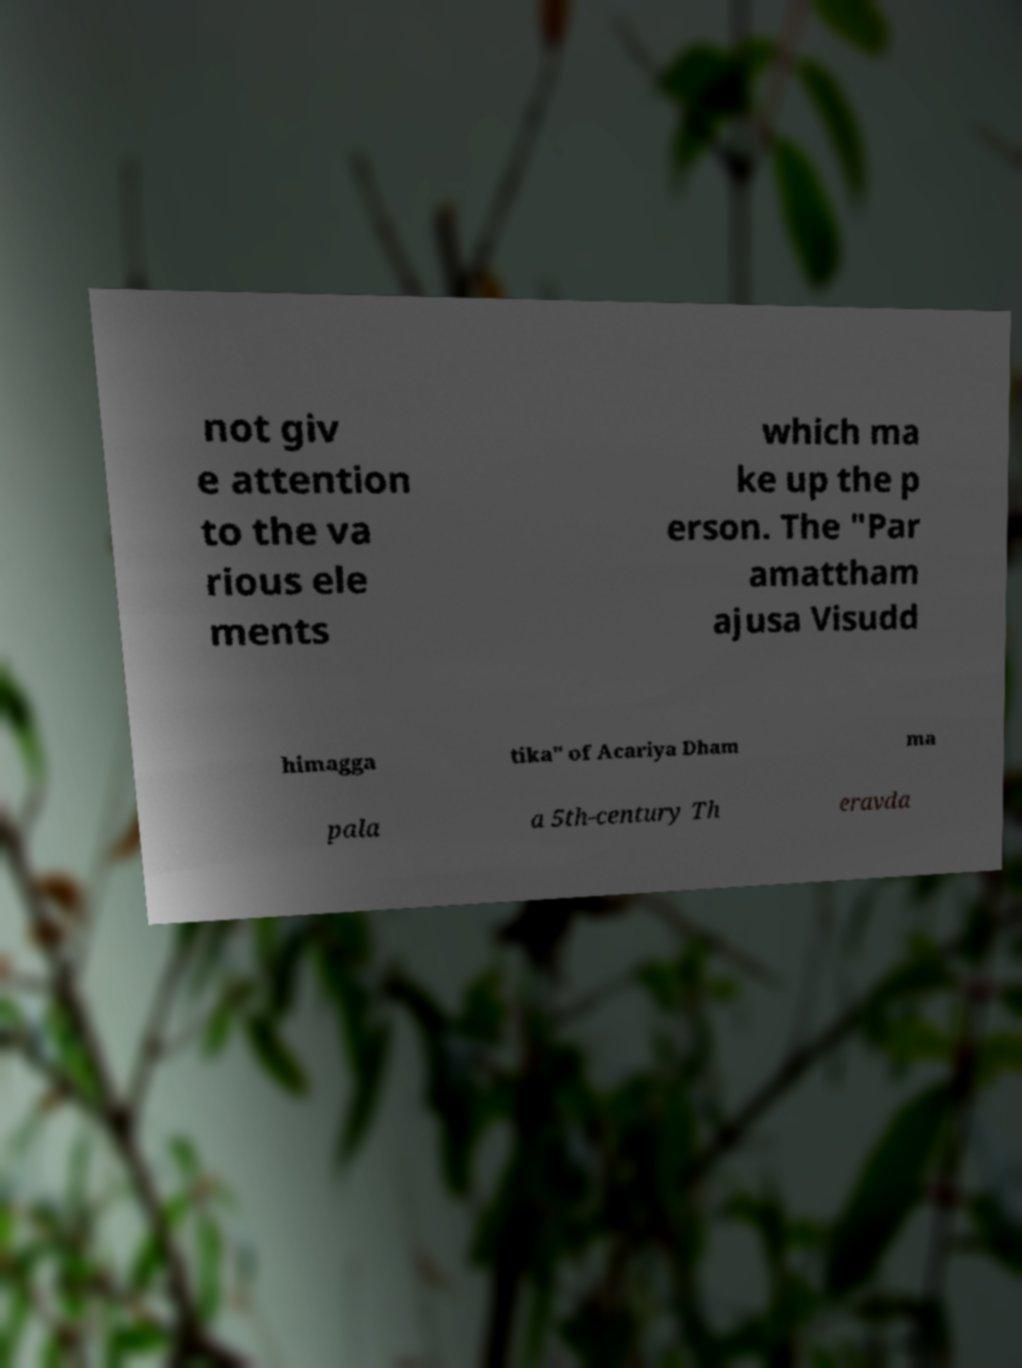Can you accurately transcribe the text from the provided image for me? not giv e attention to the va rious ele ments which ma ke up the p erson. The "Par amattham ajusa Visudd himagga tika" of Acariya Dham ma pala a 5th-century Th eravda 